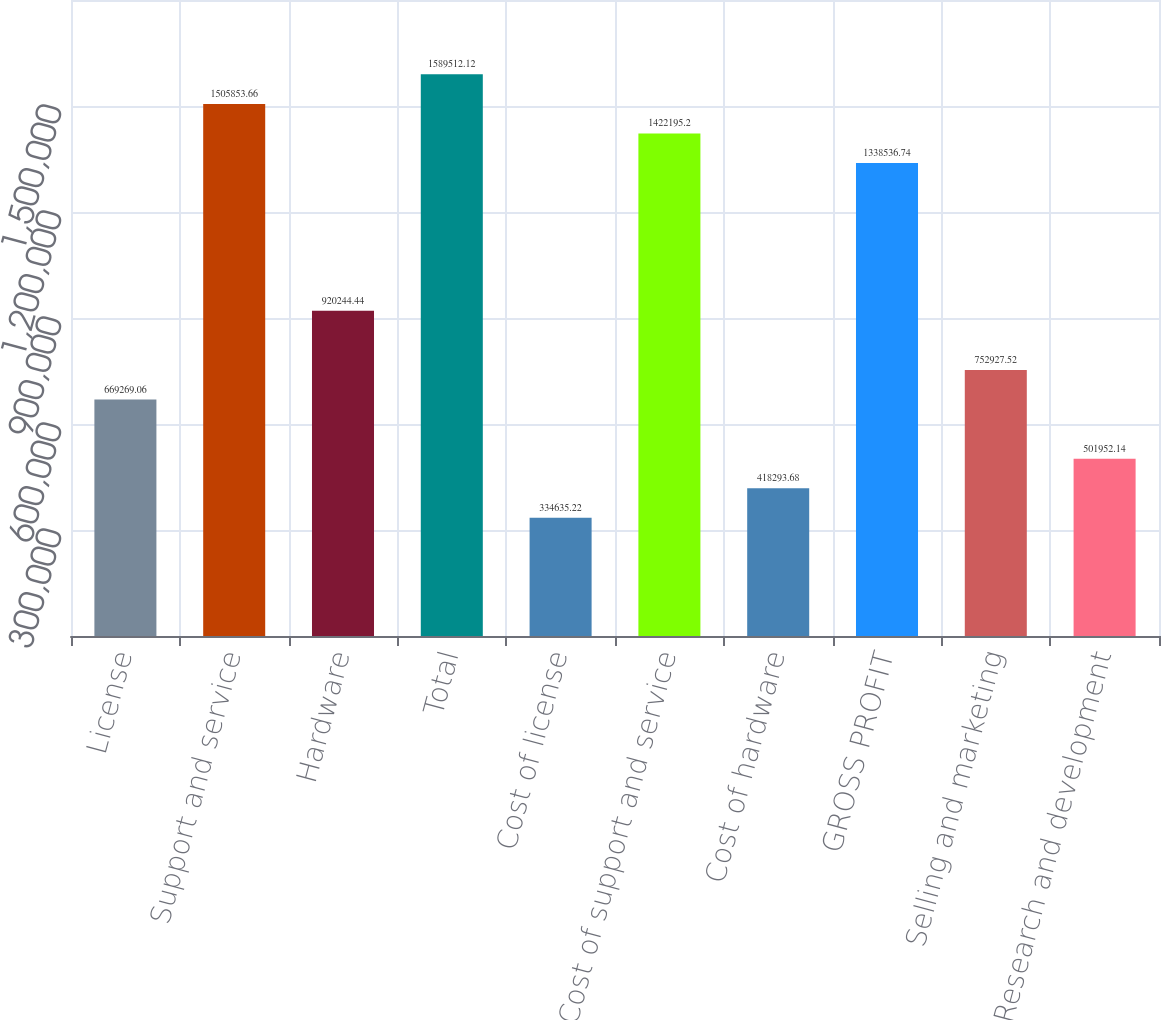Convert chart. <chart><loc_0><loc_0><loc_500><loc_500><bar_chart><fcel>License<fcel>Support and service<fcel>Hardware<fcel>Total<fcel>Cost of license<fcel>Cost of support and service<fcel>Cost of hardware<fcel>GROSS PROFIT<fcel>Selling and marketing<fcel>Research and development<nl><fcel>669269<fcel>1.50585e+06<fcel>920244<fcel>1.58951e+06<fcel>334635<fcel>1.4222e+06<fcel>418294<fcel>1.33854e+06<fcel>752928<fcel>501952<nl></chart> 